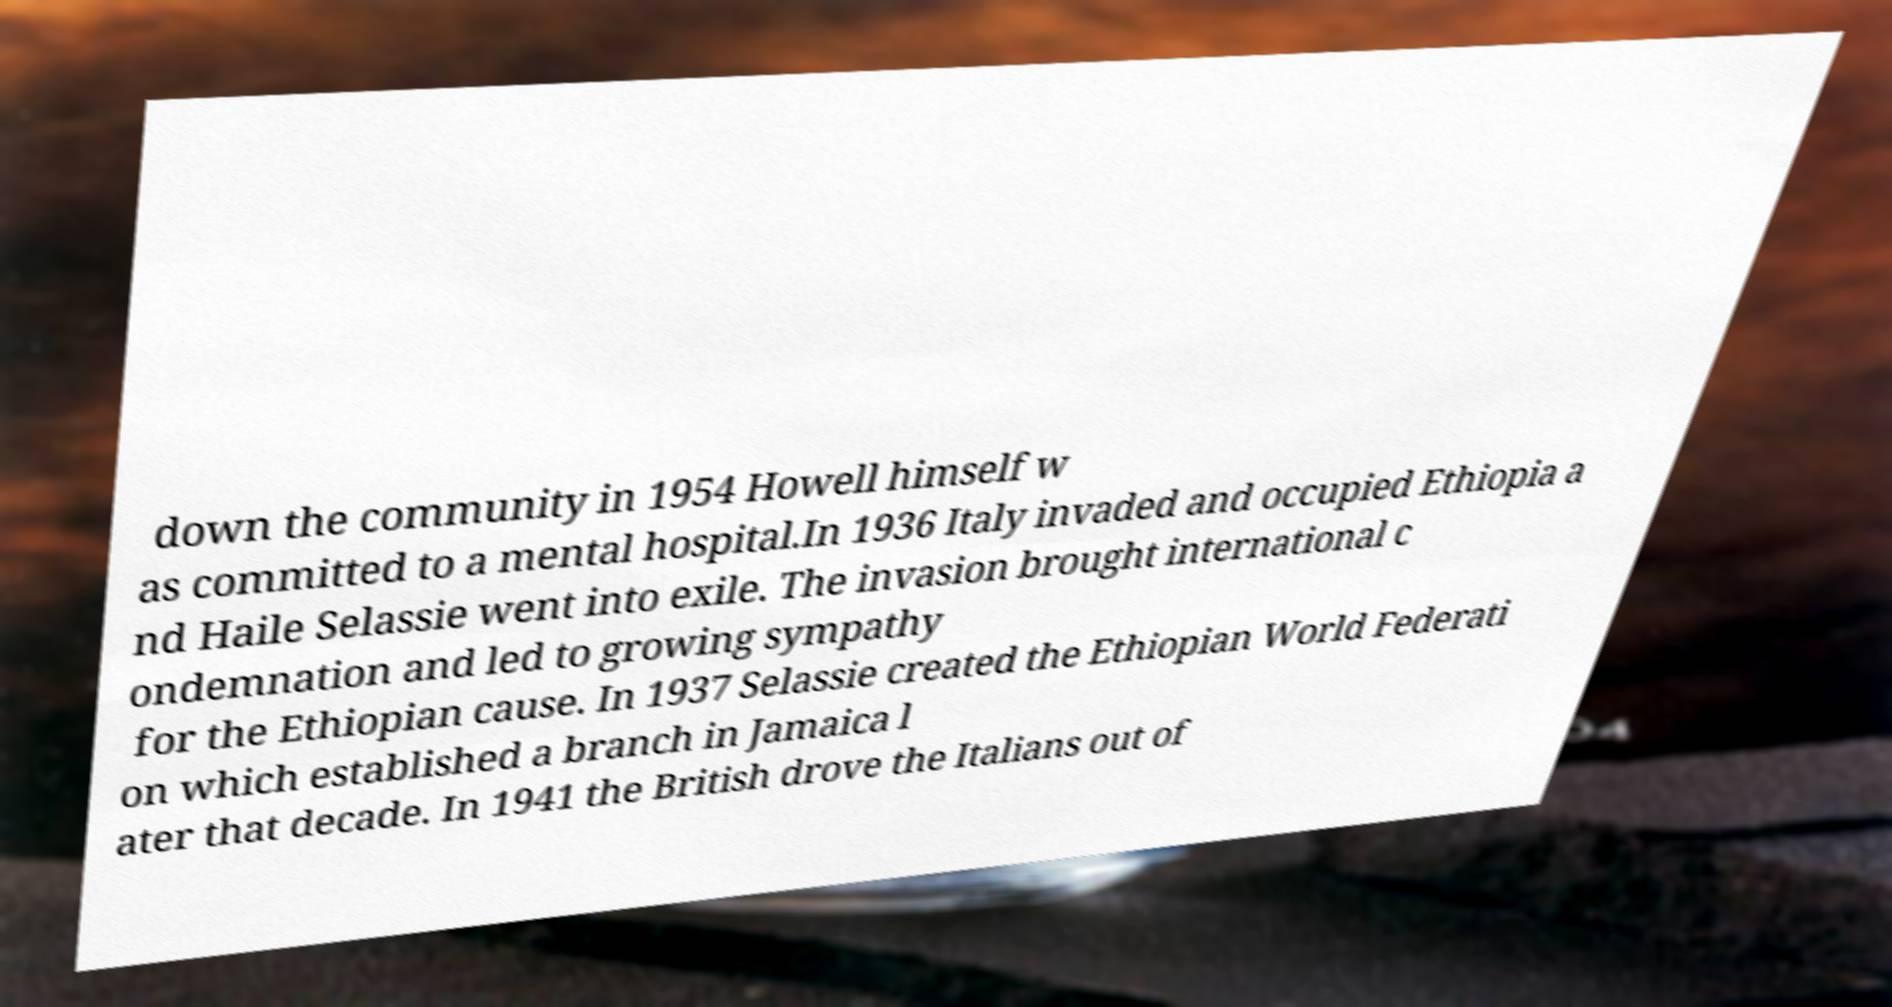Can you accurately transcribe the text from the provided image for me? down the community in 1954 Howell himself w as committed to a mental hospital.In 1936 Italy invaded and occupied Ethiopia a nd Haile Selassie went into exile. The invasion brought international c ondemnation and led to growing sympathy for the Ethiopian cause. In 1937 Selassie created the Ethiopian World Federati on which established a branch in Jamaica l ater that decade. In 1941 the British drove the Italians out of 